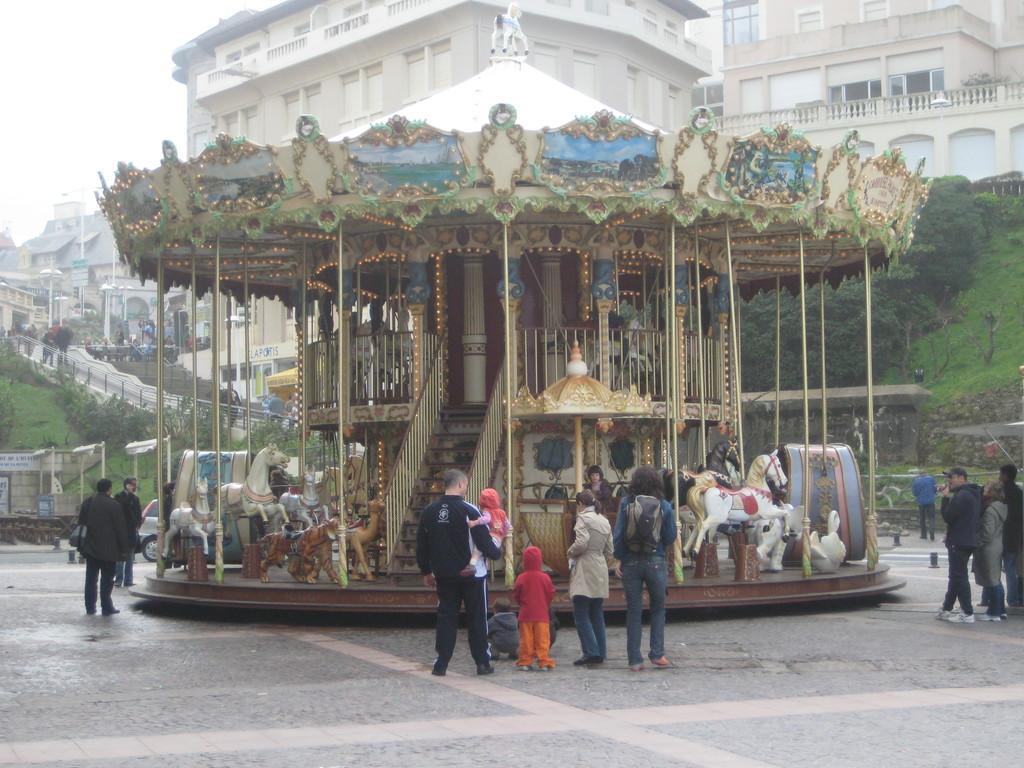How would you summarize this image in a sentence or two? In this image I can see people are standing on the ground. In the background I can see buildings, trees, the grass and the sky. I can also see vehicle and some other objects on the ground. 